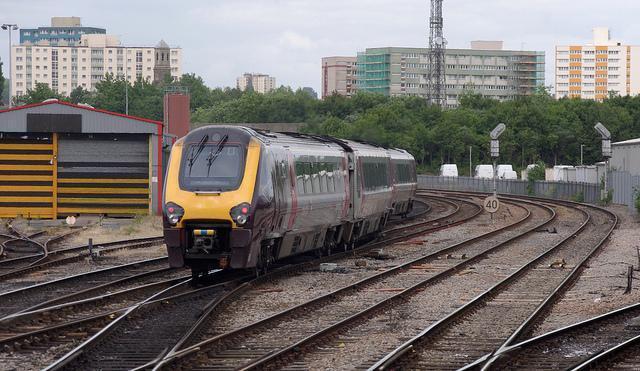How many cars do you see?
Give a very brief answer. 3. How many people are sitting at the table?
Give a very brief answer. 0. 